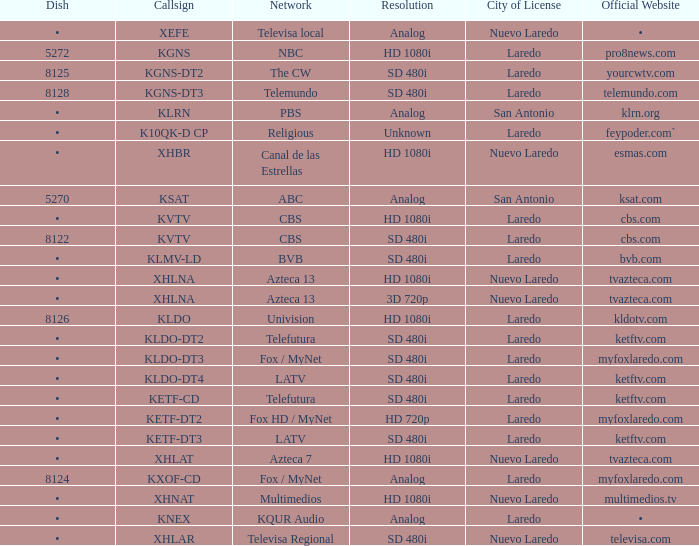Specify the city that holds the license for a 480i sd resolution and has telemundo.com as its official website. Laredo. 